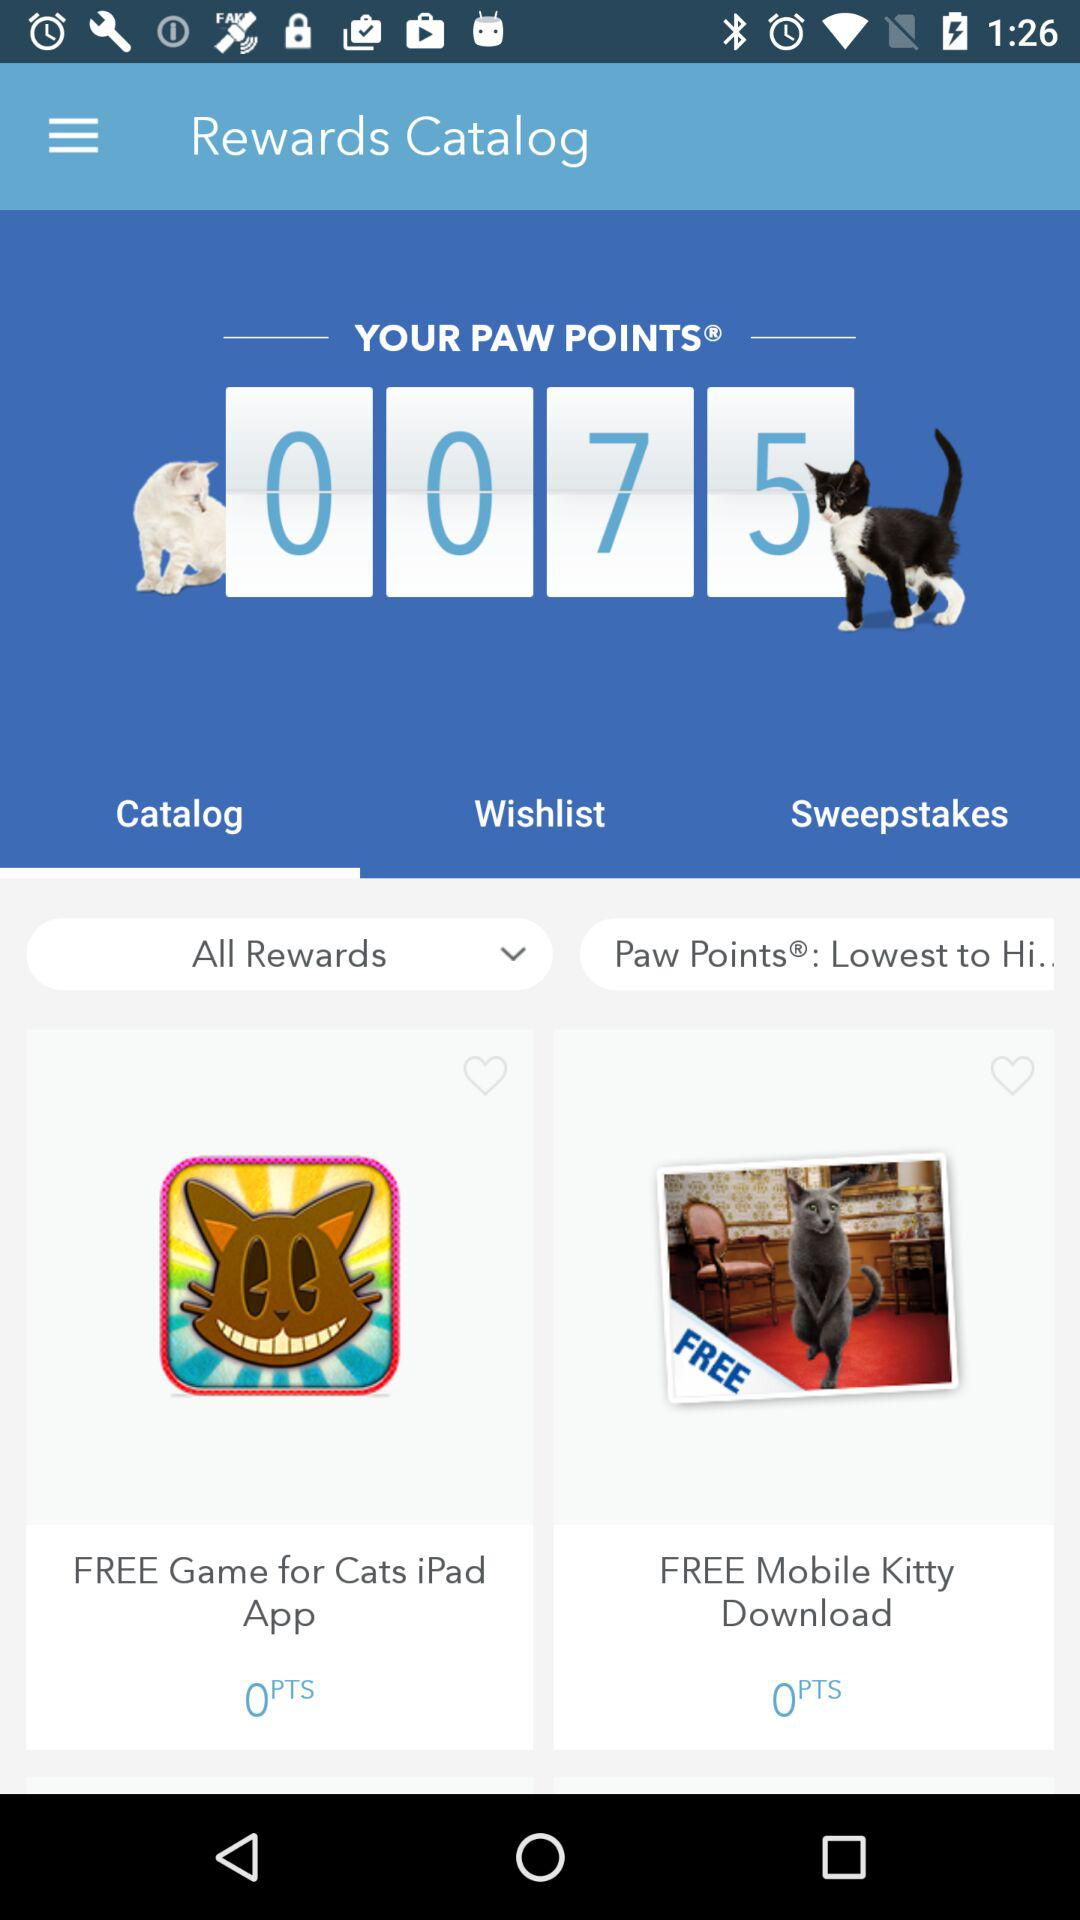How many paw points are needed for "Cats iPad" application? The paw points that are needed is 0. 